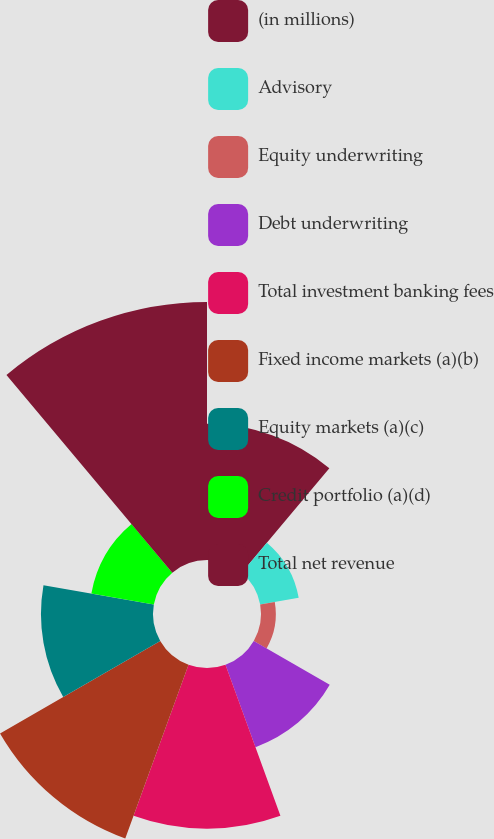<chart> <loc_0><loc_0><loc_500><loc_500><pie_chart><fcel>(in millions)<fcel>Advisory<fcel>Equity underwriting<fcel>Debt underwriting<fcel>Total investment banking fees<fcel>Fixed income markets (a)(b)<fcel>Equity markets (a)(c)<fcel>Credit portfolio (a)(d)<fcel>Total net revenue<nl><fcel>12.9%<fcel>3.7%<fcel>1.4%<fcel>8.3%<fcel>15.2%<fcel>17.5%<fcel>10.6%<fcel>6.0%<fcel>24.41%<nl></chart> 